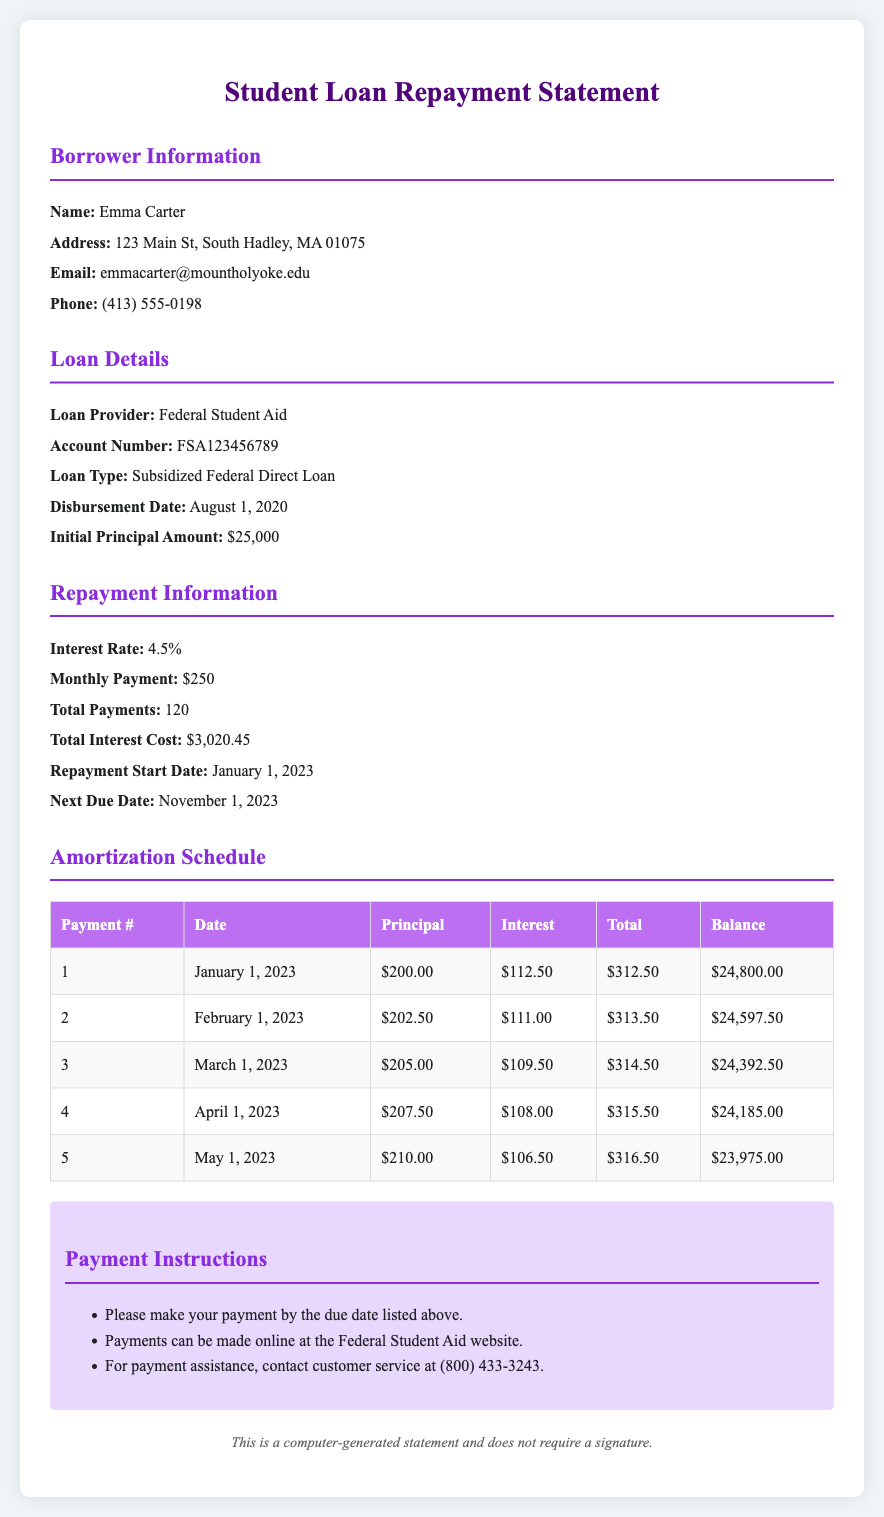What is the borrower's name? The borrower's name is explicitly stated in the document as Emma Carter.
Answer: Emma Carter What is the loan provider? The loan provider is mentioned in the loan details section as Federal Student Aid.
Answer: Federal Student Aid What is the interest rate? The interest rate is provided in the repayment information section as 4.5%.
Answer: 4.5% When did the repayment start? The repayment start date is specified in the repayment information section as January 1, 2023.
Answer: January 1, 2023 What is the monthly payment amount? The monthly payment amount is stated in the repayment information section as $250.
Answer: $250 How much was the initial principal amount? The initial principal amount is detailed in the loan details section, which is $25,000.
Answer: $25,000 What is the total interest cost? The total interest cost is provided in the repayment information section, which is $3,020.45.
Answer: $3,020.45 What is the balance after the first payment? The balance after the first payment is given in the amortization schedule as $24,800.00.
Answer: $24,800.00 How many total payments are there? The total number of payments is indicated in the repayment section as 120.
Answer: 120 What is the next due date? The next due date is specified in the repayment information section as November 1, 2023.
Answer: November 1, 2023 